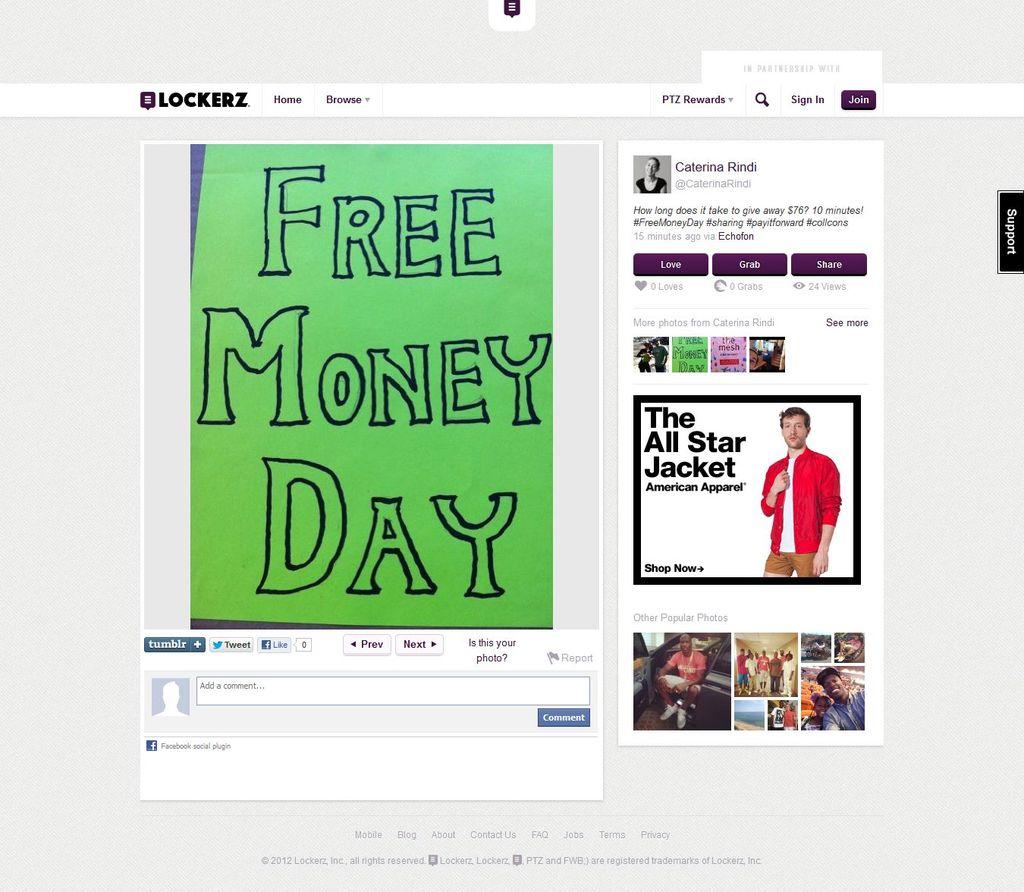What day is it?
Your answer should be compact. Free money day. What website is being used?
Your answer should be compact. Lockerz. 